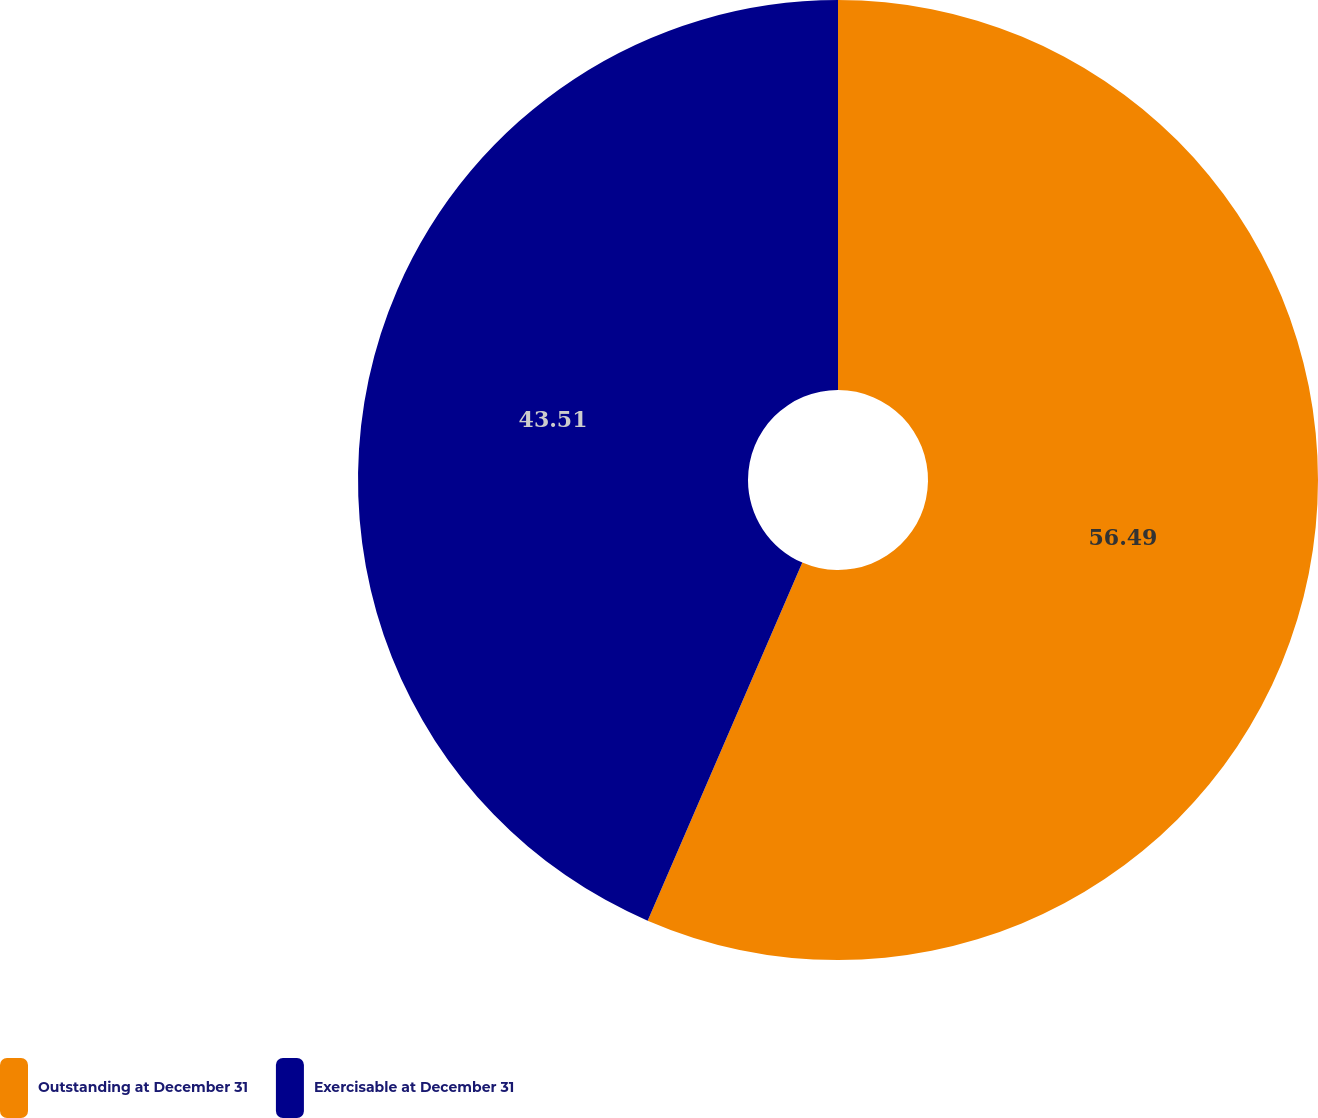Convert chart to OTSL. <chart><loc_0><loc_0><loc_500><loc_500><pie_chart><fcel>Outstanding at December 31<fcel>Exercisable at December 31<nl><fcel>56.49%<fcel>43.51%<nl></chart> 